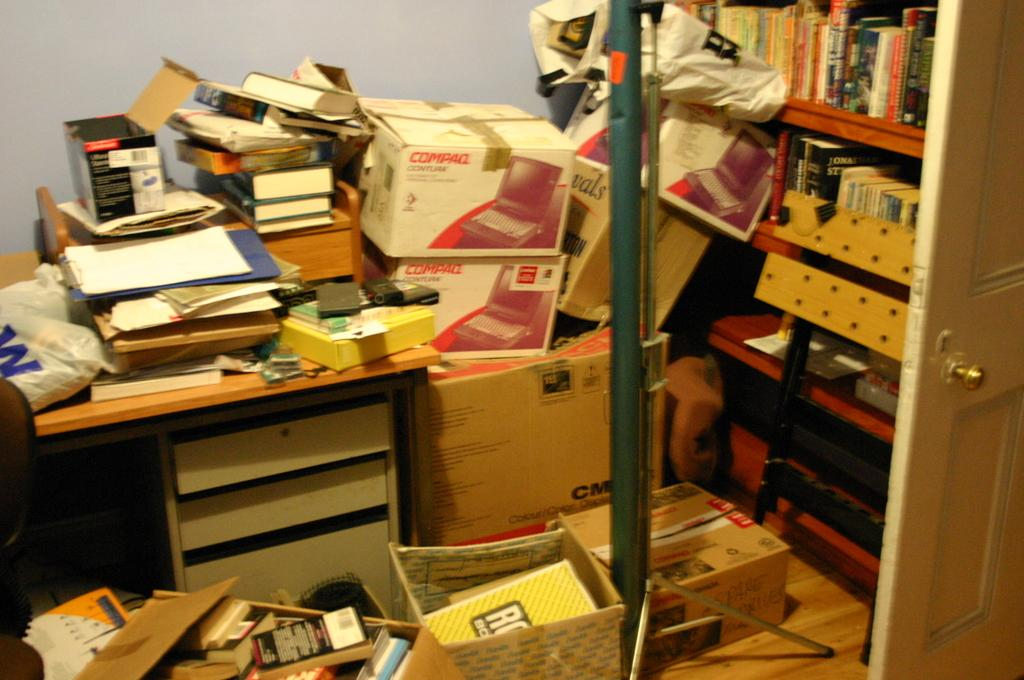<image>
Summarize the visual content of the image. A number of Compaq and other boxes are stacked up in a room. 